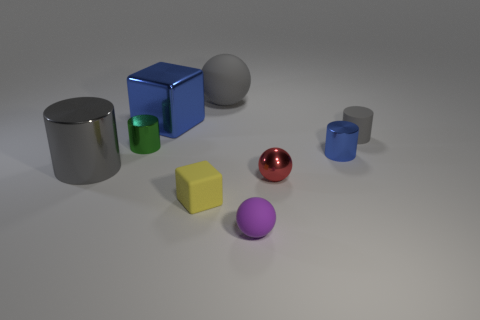Subtract all blue cylinders. How many cylinders are left? 3 Subtract all shiny cylinders. How many cylinders are left? 1 Add 1 blue shiny objects. How many objects exist? 10 Subtract all brown cylinders. Subtract all gray blocks. How many cylinders are left? 4 Subtract all spheres. How many objects are left? 6 Subtract all purple metal cylinders. Subtract all tiny rubber objects. How many objects are left? 6 Add 1 gray shiny objects. How many gray shiny objects are left? 2 Add 7 big red rubber things. How many big red rubber things exist? 7 Subtract 0 purple cylinders. How many objects are left? 9 